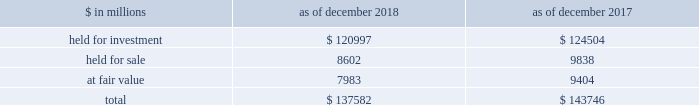The goldman sachs group , inc .
And subsidiaries notes to consolidated financial statements lending commitments the firm 2019s lending commitments are agreements to lend with fixed termination dates and depend on the satisfaction of all contractual conditions to borrowing .
These commitments are presented net of amounts syndicated to third parties .
The total commitment amount does not necessarily reflect actual future cash flows because the firm may syndicate all or substantial additional portions of these commitments .
In addition , commitments can expire unused or be reduced or cancelled at the counterparty 2019s request .
The table below presents information about lending commitments. .
In the table above : 2030 held for investment lending commitments are accounted for on an accrual basis .
See note 9 for further information about such commitments .
2030 held for sale lending commitments are accounted for at the lower of cost or fair value .
2030 gains or losses related to lending commitments at fair value , if any , are generally recorded , net of any fees in other principal transactions .
2030 substantially all lending commitments relates to the firm 2019s investing & lending segment .
Commercial lending .
The firm 2019s commercial lending commitments were primarily extended to investment-grade corporate borrowers .
Such commitments included $ 93.99 billion as of december 2018 and $ 85.98 billion as of december 2017 , related to relationship lending activities ( principally used for operating and general corporate purposes ) and $ 27.92 billion as of december 2018 and $ 42.41 billion as of december 2017 , related to other investment banking activities ( generally extended for contingent acquisition financing and are often intended to be short-term in nature , as borrowers often seek to replace them with other funding sources ) .
The firm also extends lending commitments in connection with other types of corporate lending , as well as commercial real estate financing .
See note 9 for further information about funded loans .
Sumitomo mitsui financial group , inc .
( smfg ) provides the firm with credit loss protection on certain approved loan commitments ( primarily investment-grade commercial lending commitments ) .
The notional amount of such loan commitments was $ 15.52 billion as of december 2018 and $ 25.70 billion as of december 2017 .
The credit loss protection on loan commitments provided by smfg is generally limited to 95% ( 95 % ) of the first loss the firm realizes on such commitments , up to a maximum of approximately $ 950 million .
In addition , subject to the satisfaction of certain conditions , upon the firm 2019s request , smfg will provide protection for 70% ( 70 % ) of additional losses on such commitments , up to a maximum of $ 1.0 billion , of which $ 550 million of protection had been provided as of both december 2018 and december 2017 .
The firm also uses other financial instruments to mitigate credit risks related to certain commitments not covered by smfg .
These instruments primarily include credit default swaps that reference the same or similar underlying instrument or entity , or credit default swaps that reference a market index .
Warehouse financing .
The firm provides financing to clients who warehouse financial assets .
These arrangements are secured by the warehoused assets , primarily consisting of consumer and corporate loans .
Contingent and forward starting collateralized agreements / forward starting collateralized financings forward starting collateralized agreements includes resale and securities borrowing agreements , and forward starting collateralized financings includes repurchase and secured lending agreements that settle at a future date , generally within three business days .
The firm also enters into commitments to provide contingent financing to its clients and counterparties through resale agreements .
The firm 2019s funding of these commitments depends on the satisfaction of all contractual conditions to the resale agreement and these commitments can expire unused .
Letters of credit the firm has commitments under letters of credit issued by various banks which the firm provides to counterparties in lieu of securities or cash to satisfy various collateral and margin deposit requirements .
Investment commitments investment commitments includes commitments to invest in private equity , real estate and other assets directly and through funds that the firm raises and manages .
Investment commitments included $ 2.42 billion as of december 2018 and $ 2.09 billion as of december 2017 , related to commitments to invest in funds managed by the firm .
If these commitments are called , they would be funded at market value on the date of investment .
Goldman sachs 2018 form 10-k 159 .
What is the growth rate in the balance of lending commitments held for investment in 2018? 
Computations: ((120997 - 124504) / 124504)
Answer: -0.02817. 